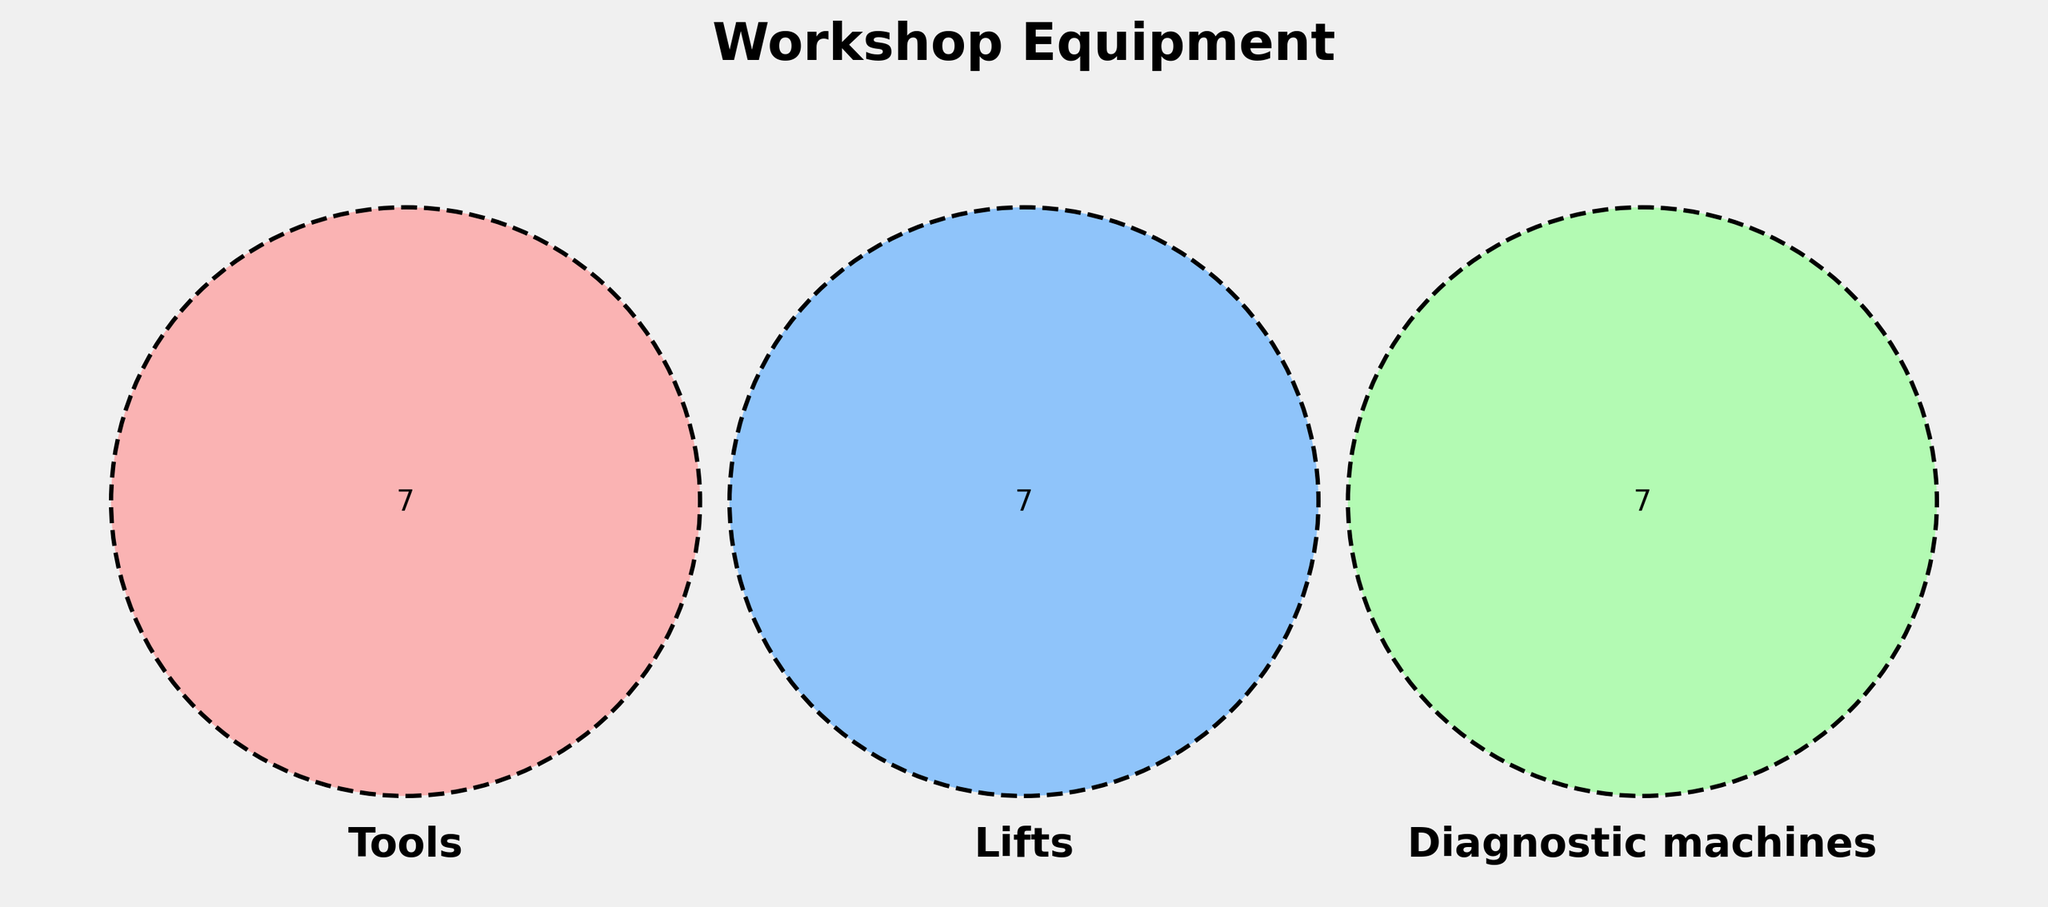What is the title of the plot? The title is located at the top of the plot, often in bold text for emphasis. It describes the content of the venn diagram.
Answer: Workshop Equipment Which set has the largest unique category? Look at the segments of the venn diagram that represent unique elements for each set. The largest unique segment will represent the set with the most exclusive items.
Answer: Tools How many items are common to all three categories? Find the central section where all three circles overlap. Count the number of items in that section.
Answer: 0 Are there any items that appear in both the Tools and Diagnostic machines categories but not in Lifts? Look at the intersection of the Tools and Diagnostic machines circles excluding any overlap with the Lifts circle.
Answer: No Which sections have overlapping items between Lifts and Diagnostic machines only? Identify the section where only the Lifts and Diagnostic machines circles intersect and count the visible overlap items.
Answer: 0 How many items are unique to Lifts? Look at the section of the Lifts circle that does not overlap with any other circles and count the items.
Answer: 6 Compare the number of unique items between Tools and Diagnostic machines. Which has more? Count the number of unique items in the section of the Tools circle that does not overlap with any other circle and do the same for Diagnostic machines. Compare them.
Answer: Tools Is there any overlap between the Tools and Lifts categories? Look where the Tools and Lifts circles intersect and see if there are any items in this section.
Answer: No 